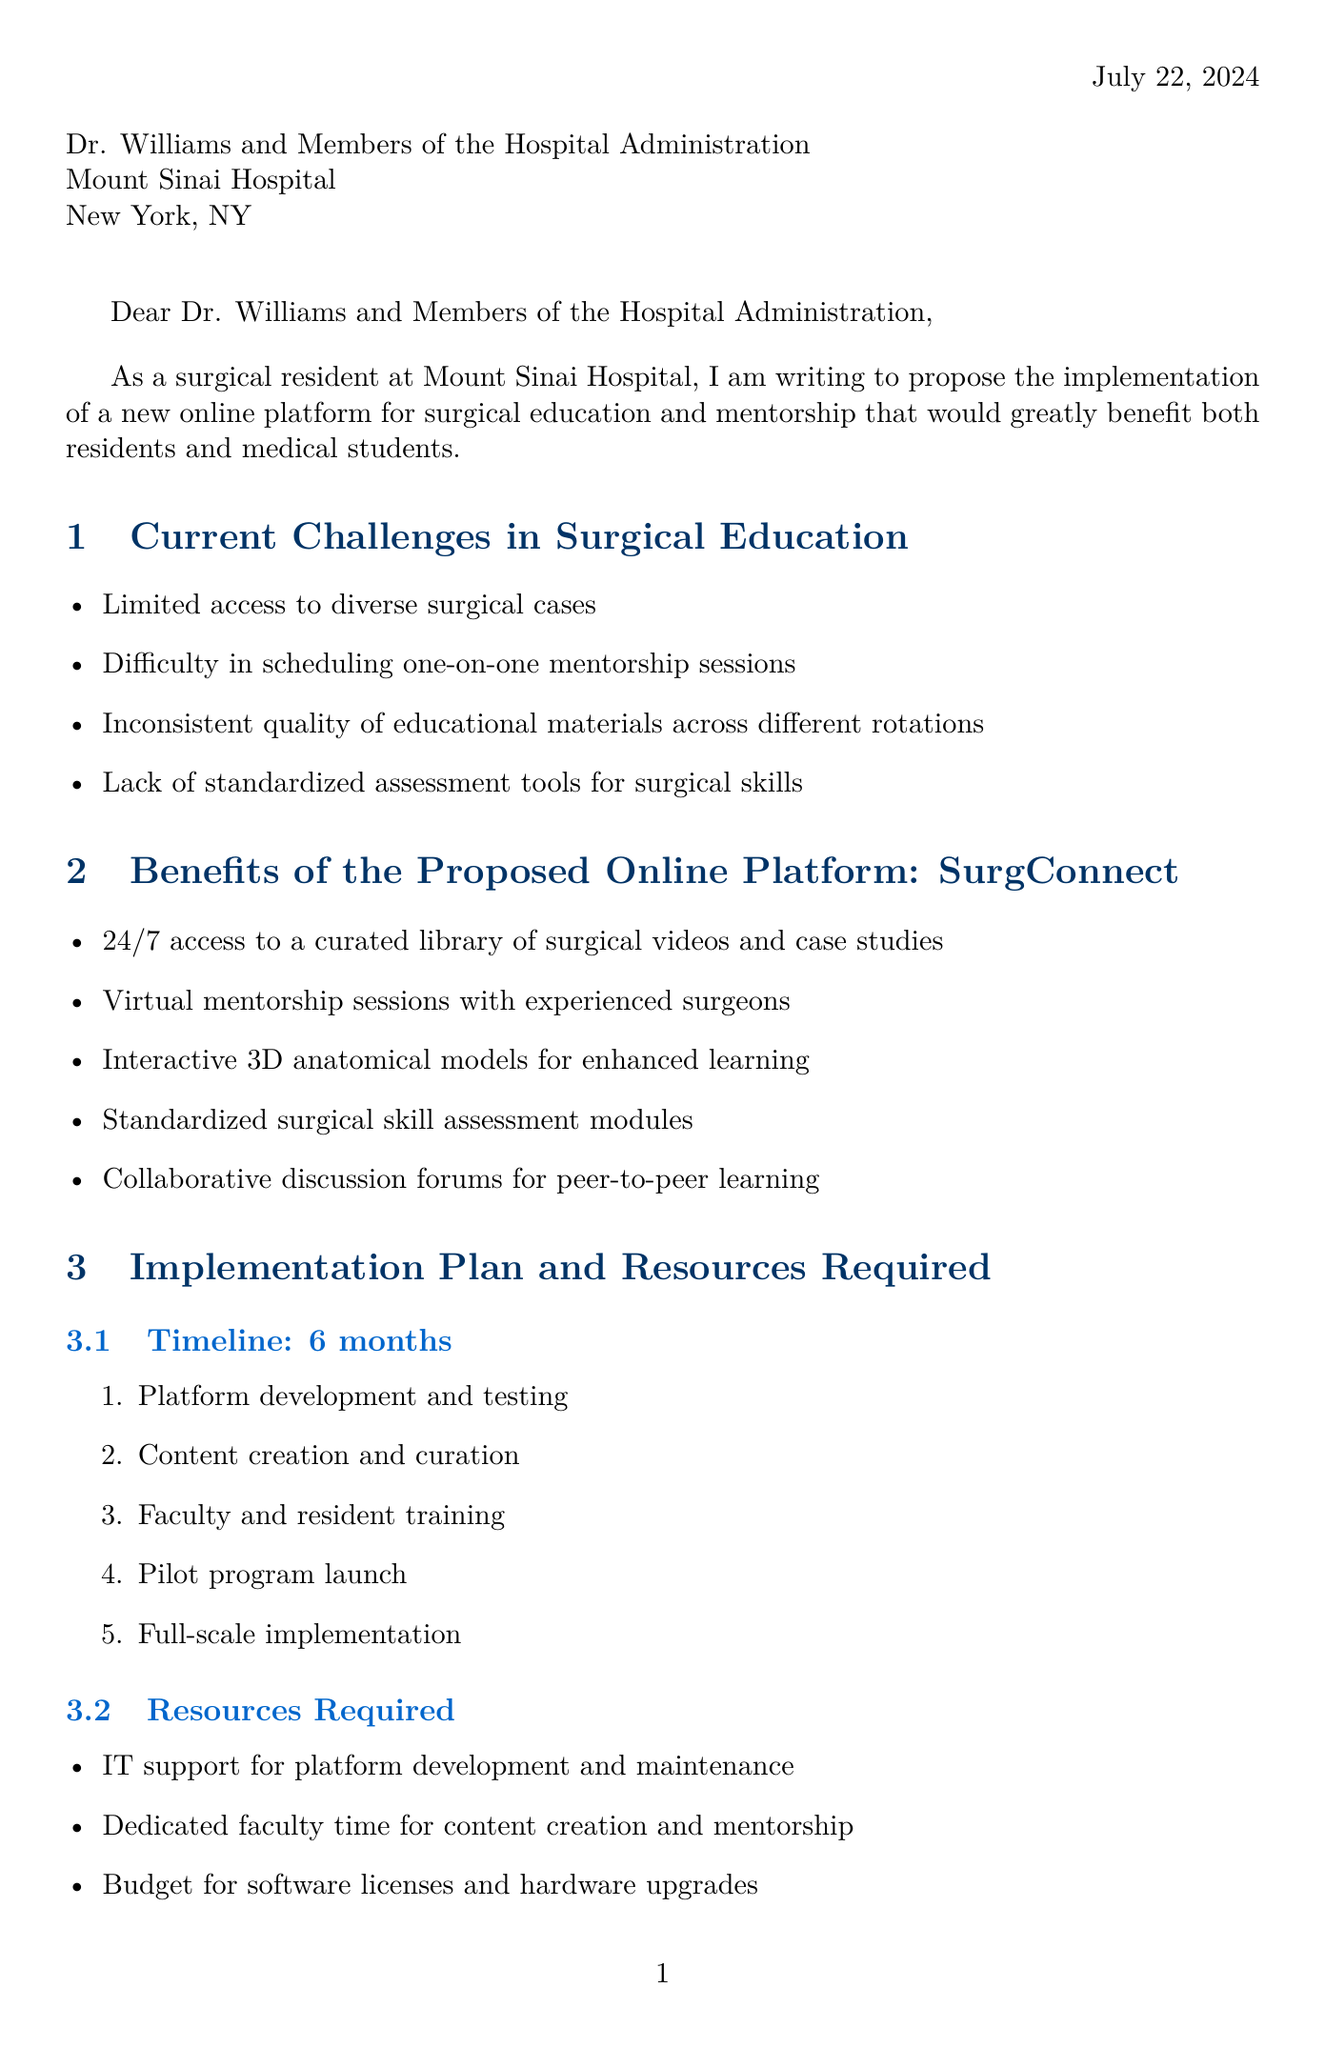What is the proposed platform name? The proposed platform for surgical education and mentorship is named in the document.
Answer: SurgConnect How many months is the implementation timeline? The document specifies the timeline for implementation in months.
Answer: 6 months What is the initial setup cost? This cost is outlined in the document under estimated costs.
Answer: $150,000 What is one potential partner mentioned? The document lists potential partners for the proposed platform.
Answer: Medtronic What is the primary benefit of 24/7 access to a curated library? The benefit refers to the increased access to educational resources.
Answer: Access to surgical videos and case studies What study is referenced for supporting data? The document cites a specific organization related to a study on online learning platforms.
Answer: American College of Surgeons What are the expected improvements in resident performance? The document discusses several expected outcomes linked to the platform's usage.
Answer: Improved surgical skills and knowledge retention Which institution is mentioned alongside Mayo Clinic? The document includes peer institutions that have implemented similar platforms.
Answer: Johns Hopkins What does the proposed platform aim to enhance in terms of education? The document outlines the core objectives of the proposed platform.
Answer: Surgical education and mentorship 